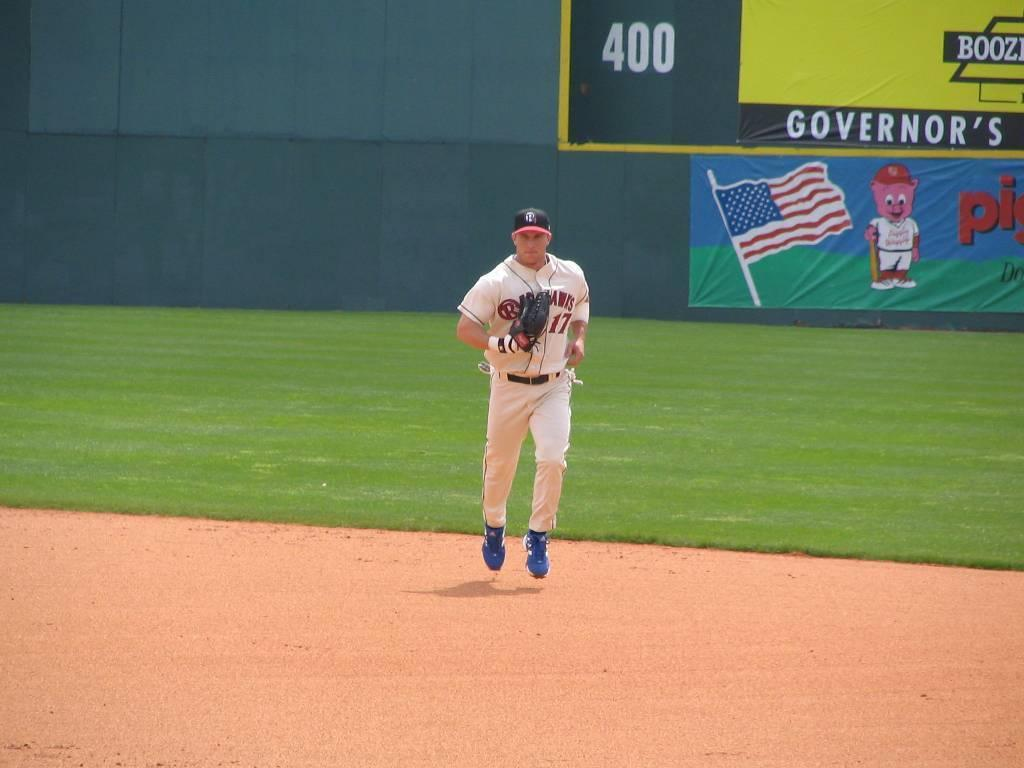<image>
Share a concise interpretation of the image provided. Professional base ball player coming in from the outfield which has banners for Piggly Wiggly and Governers on the back wall. 